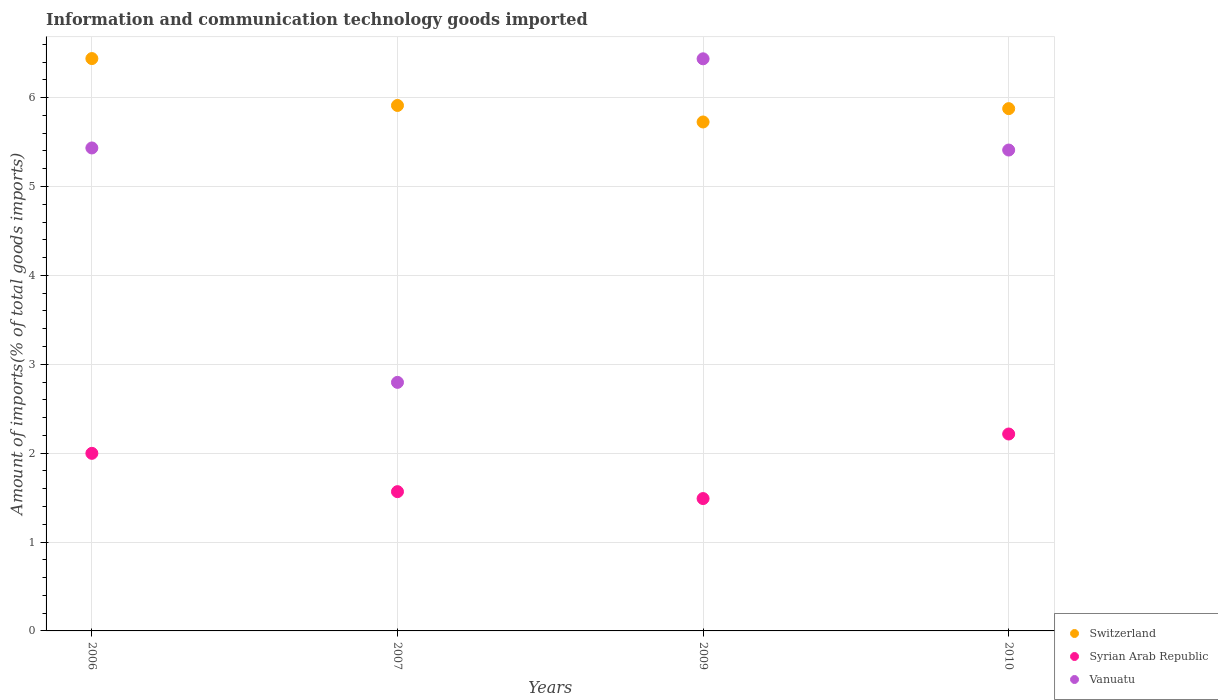How many different coloured dotlines are there?
Provide a short and direct response. 3. Is the number of dotlines equal to the number of legend labels?
Provide a short and direct response. Yes. What is the amount of goods imported in Syrian Arab Republic in 2006?
Make the answer very short. 2. Across all years, what is the maximum amount of goods imported in Switzerland?
Offer a terse response. 6.44. Across all years, what is the minimum amount of goods imported in Switzerland?
Keep it short and to the point. 5.73. In which year was the amount of goods imported in Switzerland minimum?
Offer a terse response. 2009. What is the total amount of goods imported in Syrian Arab Republic in the graph?
Your response must be concise. 7.27. What is the difference between the amount of goods imported in Switzerland in 2006 and that in 2009?
Your answer should be very brief. 0.71. What is the difference between the amount of goods imported in Syrian Arab Republic in 2009 and the amount of goods imported in Vanuatu in 2007?
Provide a short and direct response. -1.31. What is the average amount of goods imported in Vanuatu per year?
Keep it short and to the point. 5.02. In the year 2009, what is the difference between the amount of goods imported in Syrian Arab Republic and amount of goods imported in Switzerland?
Make the answer very short. -4.24. In how many years, is the amount of goods imported in Syrian Arab Republic greater than 2.2 %?
Your answer should be compact. 1. What is the ratio of the amount of goods imported in Vanuatu in 2006 to that in 2007?
Provide a succinct answer. 1.94. Is the amount of goods imported in Switzerland in 2006 less than that in 2009?
Make the answer very short. No. Is the difference between the amount of goods imported in Syrian Arab Republic in 2007 and 2010 greater than the difference between the amount of goods imported in Switzerland in 2007 and 2010?
Provide a succinct answer. No. What is the difference between the highest and the second highest amount of goods imported in Syrian Arab Republic?
Keep it short and to the point. 0.22. What is the difference between the highest and the lowest amount of goods imported in Vanuatu?
Make the answer very short. 3.64. Is it the case that in every year, the sum of the amount of goods imported in Syrian Arab Republic and amount of goods imported in Vanuatu  is greater than the amount of goods imported in Switzerland?
Ensure brevity in your answer.  No. Does the amount of goods imported in Syrian Arab Republic monotonically increase over the years?
Keep it short and to the point. No. Is the amount of goods imported in Vanuatu strictly greater than the amount of goods imported in Switzerland over the years?
Keep it short and to the point. No. How many dotlines are there?
Ensure brevity in your answer.  3. What is the difference between two consecutive major ticks on the Y-axis?
Offer a very short reply. 1. Where does the legend appear in the graph?
Your response must be concise. Bottom right. How are the legend labels stacked?
Your answer should be very brief. Vertical. What is the title of the graph?
Your answer should be compact. Information and communication technology goods imported. What is the label or title of the X-axis?
Your answer should be compact. Years. What is the label or title of the Y-axis?
Provide a short and direct response. Amount of imports(% of total goods imports). What is the Amount of imports(% of total goods imports) of Switzerland in 2006?
Give a very brief answer. 6.44. What is the Amount of imports(% of total goods imports) of Syrian Arab Republic in 2006?
Give a very brief answer. 2. What is the Amount of imports(% of total goods imports) of Vanuatu in 2006?
Keep it short and to the point. 5.43. What is the Amount of imports(% of total goods imports) of Switzerland in 2007?
Your response must be concise. 5.91. What is the Amount of imports(% of total goods imports) of Syrian Arab Republic in 2007?
Your response must be concise. 1.57. What is the Amount of imports(% of total goods imports) of Vanuatu in 2007?
Keep it short and to the point. 2.8. What is the Amount of imports(% of total goods imports) of Switzerland in 2009?
Provide a succinct answer. 5.73. What is the Amount of imports(% of total goods imports) in Syrian Arab Republic in 2009?
Ensure brevity in your answer.  1.49. What is the Amount of imports(% of total goods imports) of Vanuatu in 2009?
Provide a succinct answer. 6.44. What is the Amount of imports(% of total goods imports) in Switzerland in 2010?
Your answer should be very brief. 5.88. What is the Amount of imports(% of total goods imports) of Syrian Arab Republic in 2010?
Provide a short and direct response. 2.22. What is the Amount of imports(% of total goods imports) in Vanuatu in 2010?
Ensure brevity in your answer.  5.41. Across all years, what is the maximum Amount of imports(% of total goods imports) of Switzerland?
Offer a terse response. 6.44. Across all years, what is the maximum Amount of imports(% of total goods imports) in Syrian Arab Republic?
Provide a succinct answer. 2.22. Across all years, what is the maximum Amount of imports(% of total goods imports) of Vanuatu?
Provide a short and direct response. 6.44. Across all years, what is the minimum Amount of imports(% of total goods imports) in Switzerland?
Offer a terse response. 5.73. Across all years, what is the minimum Amount of imports(% of total goods imports) of Syrian Arab Republic?
Provide a succinct answer. 1.49. Across all years, what is the minimum Amount of imports(% of total goods imports) of Vanuatu?
Give a very brief answer. 2.8. What is the total Amount of imports(% of total goods imports) in Switzerland in the graph?
Keep it short and to the point. 23.95. What is the total Amount of imports(% of total goods imports) of Syrian Arab Republic in the graph?
Ensure brevity in your answer.  7.27. What is the total Amount of imports(% of total goods imports) in Vanuatu in the graph?
Keep it short and to the point. 20.08. What is the difference between the Amount of imports(% of total goods imports) in Switzerland in 2006 and that in 2007?
Your response must be concise. 0.53. What is the difference between the Amount of imports(% of total goods imports) in Syrian Arab Republic in 2006 and that in 2007?
Ensure brevity in your answer.  0.43. What is the difference between the Amount of imports(% of total goods imports) in Vanuatu in 2006 and that in 2007?
Your response must be concise. 2.64. What is the difference between the Amount of imports(% of total goods imports) in Switzerland in 2006 and that in 2009?
Provide a succinct answer. 0.71. What is the difference between the Amount of imports(% of total goods imports) of Syrian Arab Republic in 2006 and that in 2009?
Ensure brevity in your answer.  0.51. What is the difference between the Amount of imports(% of total goods imports) of Vanuatu in 2006 and that in 2009?
Provide a succinct answer. -1. What is the difference between the Amount of imports(% of total goods imports) of Switzerland in 2006 and that in 2010?
Your answer should be compact. 0.56. What is the difference between the Amount of imports(% of total goods imports) in Syrian Arab Republic in 2006 and that in 2010?
Keep it short and to the point. -0.22. What is the difference between the Amount of imports(% of total goods imports) in Vanuatu in 2006 and that in 2010?
Give a very brief answer. 0.02. What is the difference between the Amount of imports(% of total goods imports) in Switzerland in 2007 and that in 2009?
Ensure brevity in your answer.  0.19. What is the difference between the Amount of imports(% of total goods imports) of Syrian Arab Republic in 2007 and that in 2009?
Offer a very short reply. 0.08. What is the difference between the Amount of imports(% of total goods imports) of Vanuatu in 2007 and that in 2009?
Offer a very short reply. -3.64. What is the difference between the Amount of imports(% of total goods imports) in Switzerland in 2007 and that in 2010?
Provide a succinct answer. 0.04. What is the difference between the Amount of imports(% of total goods imports) of Syrian Arab Republic in 2007 and that in 2010?
Ensure brevity in your answer.  -0.65. What is the difference between the Amount of imports(% of total goods imports) in Vanuatu in 2007 and that in 2010?
Offer a very short reply. -2.61. What is the difference between the Amount of imports(% of total goods imports) in Switzerland in 2009 and that in 2010?
Provide a short and direct response. -0.15. What is the difference between the Amount of imports(% of total goods imports) of Syrian Arab Republic in 2009 and that in 2010?
Provide a succinct answer. -0.73. What is the difference between the Amount of imports(% of total goods imports) of Vanuatu in 2009 and that in 2010?
Make the answer very short. 1.03. What is the difference between the Amount of imports(% of total goods imports) of Switzerland in 2006 and the Amount of imports(% of total goods imports) of Syrian Arab Republic in 2007?
Give a very brief answer. 4.87. What is the difference between the Amount of imports(% of total goods imports) in Switzerland in 2006 and the Amount of imports(% of total goods imports) in Vanuatu in 2007?
Give a very brief answer. 3.64. What is the difference between the Amount of imports(% of total goods imports) of Syrian Arab Republic in 2006 and the Amount of imports(% of total goods imports) of Vanuatu in 2007?
Offer a terse response. -0.8. What is the difference between the Amount of imports(% of total goods imports) in Switzerland in 2006 and the Amount of imports(% of total goods imports) in Syrian Arab Republic in 2009?
Ensure brevity in your answer.  4.95. What is the difference between the Amount of imports(% of total goods imports) in Switzerland in 2006 and the Amount of imports(% of total goods imports) in Vanuatu in 2009?
Provide a succinct answer. 0. What is the difference between the Amount of imports(% of total goods imports) of Syrian Arab Republic in 2006 and the Amount of imports(% of total goods imports) of Vanuatu in 2009?
Make the answer very short. -4.44. What is the difference between the Amount of imports(% of total goods imports) of Switzerland in 2006 and the Amount of imports(% of total goods imports) of Syrian Arab Republic in 2010?
Offer a very short reply. 4.22. What is the difference between the Amount of imports(% of total goods imports) of Switzerland in 2006 and the Amount of imports(% of total goods imports) of Vanuatu in 2010?
Provide a succinct answer. 1.03. What is the difference between the Amount of imports(% of total goods imports) in Syrian Arab Republic in 2006 and the Amount of imports(% of total goods imports) in Vanuatu in 2010?
Give a very brief answer. -3.41. What is the difference between the Amount of imports(% of total goods imports) in Switzerland in 2007 and the Amount of imports(% of total goods imports) in Syrian Arab Republic in 2009?
Make the answer very short. 4.42. What is the difference between the Amount of imports(% of total goods imports) in Switzerland in 2007 and the Amount of imports(% of total goods imports) in Vanuatu in 2009?
Give a very brief answer. -0.52. What is the difference between the Amount of imports(% of total goods imports) of Syrian Arab Republic in 2007 and the Amount of imports(% of total goods imports) of Vanuatu in 2009?
Give a very brief answer. -4.87. What is the difference between the Amount of imports(% of total goods imports) of Switzerland in 2007 and the Amount of imports(% of total goods imports) of Syrian Arab Republic in 2010?
Ensure brevity in your answer.  3.7. What is the difference between the Amount of imports(% of total goods imports) of Switzerland in 2007 and the Amount of imports(% of total goods imports) of Vanuatu in 2010?
Give a very brief answer. 0.5. What is the difference between the Amount of imports(% of total goods imports) of Syrian Arab Republic in 2007 and the Amount of imports(% of total goods imports) of Vanuatu in 2010?
Your answer should be very brief. -3.84. What is the difference between the Amount of imports(% of total goods imports) in Switzerland in 2009 and the Amount of imports(% of total goods imports) in Syrian Arab Republic in 2010?
Your answer should be compact. 3.51. What is the difference between the Amount of imports(% of total goods imports) of Switzerland in 2009 and the Amount of imports(% of total goods imports) of Vanuatu in 2010?
Keep it short and to the point. 0.32. What is the difference between the Amount of imports(% of total goods imports) in Syrian Arab Republic in 2009 and the Amount of imports(% of total goods imports) in Vanuatu in 2010?
Offer a very short reply. -3.92. What is the average Amount of imports(% of total goods imports) of Switzerland per year?
Offer a very short reply. 5.99. What is the average Amount of imports(% of total goods imports) of Syrian Arab Republic per year?
Your answer should be compact. 1.82. What is the average Amount of imports(% of total goods imports) in Vanuatu per year?
Provide a short and direct response. 5.02. In the year 2006, what is the difference between the Amount of imports(% of total goods imports) in Switzerland and Amount of imports(% of total goods imports) in Syrian Arab Republic?
Keep it short and to the point. 4.44. In the year 2006, what is the difference between the Amount of imports(% of total goods imports) in Switzerland and Amount of imports(% of total goods imports) in Vanuatu?
Give a very brief answer. 1.01. In the year 2006, what is the difference between the Amount of imports(% of total goods imports) of Syrian Arab Republic and Amount of imports(% of total goods imports) of Vanuatu?
Your answer should be very brief. -3.44. In the year 2007, what is the difference between the Amount of imports(% of total goods imports) in Switzerland and Amount of imports(% of total goods imports) in Syrian Arab Republic?
Make the answer very short. 4.34. In the year 2007, what is the difference between the Amount of imports(% of total goods imports) of Switzerland and Amount of imports(% of total goods imports) of Vanuatu?
Provide a short and direct response. 3.12. In the year 2007, what is the difference between the Amount of imports(% of total goods imports) of Syrian Arab Republic and Amount of imports(% of total goods imports) of Vanuatu?
Your answer should be very brief. -1.23. In the year 2009, what is the difference between the Amount of imports(% of total goods imports) of Switzerland and Amount of imports(% of total goods imports) of Syrian Arab Republic?
Offer a very short reply. 4.24. In the year 2009, what is the difference between the Amount of imports(% of total goods imports) in Switzerland and Amount of imports(% of total goods imports) in Vanuatu?
Provide a succinct answer. -0.71. In the year 2009, what is the difference between the Amount of imports(% of total goods imports) of Syrian Arab Republic and Amount of imports(% of total goods imports) of Vanuatu?
Give a very brief answer. -4.95. In the year 2010, what is the difference between the Amount of imports(% of total goods imports) in Switzerland and Amount of imports(% of total goods imports) in Syrian Arab Republic?
Ensure brevity in your answer.  3.66. In the year 2010, what is the difference between the Amount of imports(% of total goods imports) in Switzerland and Amount of imports(% of total goods imports) in Vanuatu?
Make the answer very short. 0.47. In the year 2010, what is the difference between the Amount of imports(% of total goods imports) in Syrian Arab Republic and Amount of imports(% of total goods imports) in Vanuatu?
Provide a succinct answer. -3.19. What is the ratio of the Amount of imports(% of total goods imports) of Switzerland in 2006 to that in 2007?
Keep it short and to the point. 1.09. What is the ratio of the Amount of imports(% of total goods imports) of Syrian Arab Republic in 2006 to that in 2007?
Give a very brief answer. 1.28. What is the ratio of the Amount of imports(% of total goods imports) of Vanuatu in 2006 to that in 2007?
Your answer should be compact. 1.94. What is the ratio of the Amount of imports(% of total goods imports) in Switzerland in 2006 to that in 2009?
Offer a terse response. 1.12. What is the ratio of the Amount of imports(% of total goods imports) of Syrian Arab Republic in 2006 to that in 2009?
Your answer should be very brief. 1.34. What is the ratio of the Amount of imports(% of total goods imports) of Vanuatu in 2006 to that in 2009?
Make the answer very short. 0.84. What is the ratio of the Amount of imports(% of total goods imports) of Switzerland in 2006 to that in 2010?
Your answer should be compact. 1.1. What is the ratio of the Amount of imports(% of total goods imports) in Syrian Arab Republic in 2006 to that in 2010?
Give a very brief answer. 0.9. What is the ratio of the Amount of imports(% of total goods imports) in Vanuatu in 2006 to that in 2010?
Ensure brevity in your answer.  1. What is the ratio of the Amount of imports(% of total goods imports) of Switzerland in 2007 to that in 2009?
Your answer should be compact. 1.03. What is the ratio of the Amount of imports(% of total goods imports) of Syrian Arab Republic in 2007 to that in 2009?
Give a very brief answer. 1.05. What is the ratio of the Amount of imports(% of total goods imports) in Vanuatu in 2007 to that in 2009?
Offer a very short reply. 0.43. What is the ratio of the Amount of imports(% of total goods imports) in Switzerland in 2007 to that in 2010?
Your answer should be very brief. 1.01. What is the ratio of the Amount of imports(% of total goods imports) of Syrian Arab Republic in 2007 to that in 2010?
Keep it short and to the point. 0.71. What is the ratio of the Amount of imports(% of total goods imports) of Vanuatu in 2007 to that in 2010?
Offer a very short reply. 0.52. What is the ratio of the Amount of imports(% of total goods imports) of Switzerland in 2009 to that in 2010?
Give a very brief answer. 0.97. What is the ratio of the Amount of imports(% of total goods imports) of Syrian Arab Republic in 2009 to that in 2010?
Your answer should be very brief. 0.67. What is the ratio of the Amount of imports(% of total goods imports) in Vanuatu in 2009 to that in 2010?
Provide a succinct answer. 1.19. What is the difference between the highest and the second highest Amount of imports(% of total goods imports) in Switzerland?
Provide a short and direct response. 0.53. What is the difference between the highest and the second highest Amount of imports(% of total goods imports) of Syrian Arab Republic?
Your answer should be very brief. 0.22. What is the difference between the highest and the lowest Amount of imports(% of total goods imports) of Switzerland?
Provide a short and direct response. 0.71. What is the difference between the highest and the lowest Amount of imports(% of total goods imports) of Syrian Arab Republic?
Offer a terse response. 0.73. What is the difference between the highest and the lowest Amount of imports(% of total goods imports) in Vanuatu?
Provide a short and direct response. 3.64. 